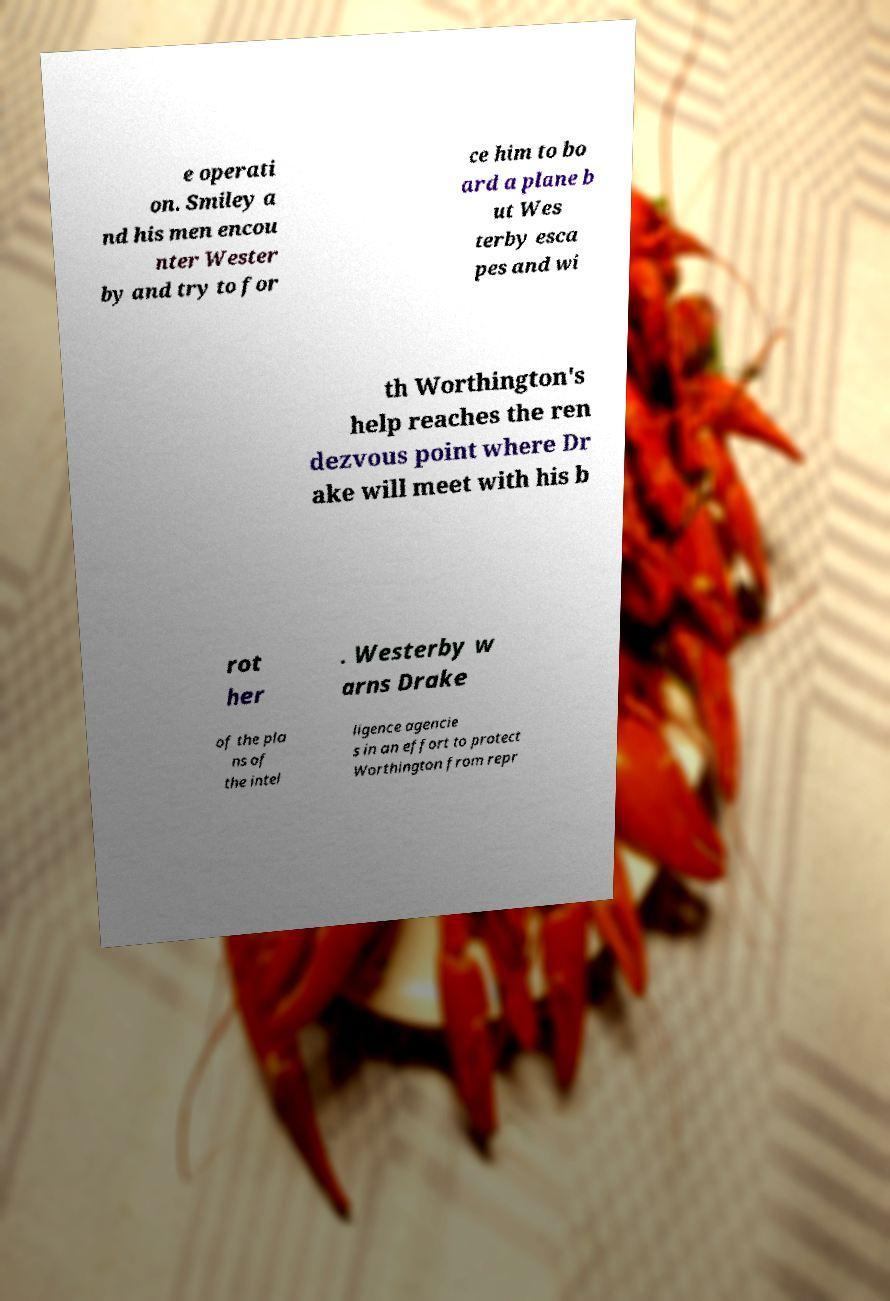For documentation purposes, I need the text within this image transcribed. Could you provide that? e operati on. Smiley a nd his men encou nter Wester by and try to for ce him to bo ard a plane b ut Wes terby esca pes and wi th Worthington's help reaches the ren dezvous point where Dr ake will meet with his b rot her . Westerby w arns Drake of the pla ns of the intel ligence agencie s in an effort to protect Worthington from repr 